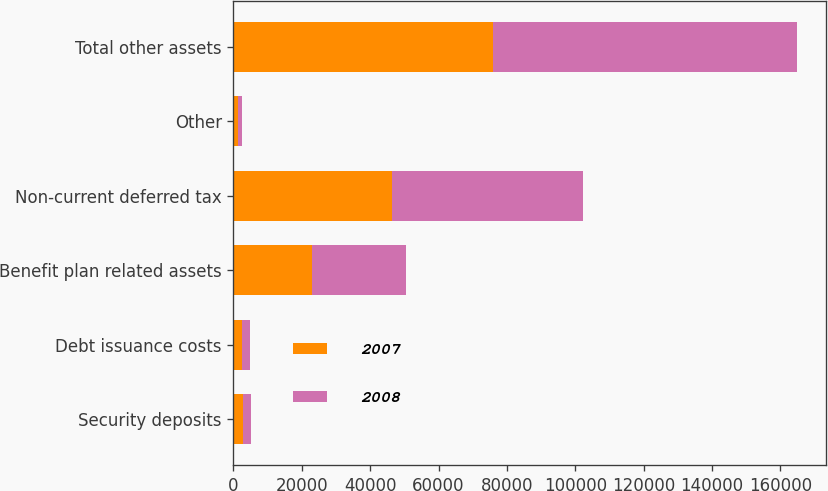Convert chart to OTSL. <chart><loc_0><loc_0><loc_500><loc_500><stacked_bar_chart><ecel><fcel>Security deposits<fcel>Debt issuance costs<fcel>Benefit plan related assets<fcel>Non-current deferred tax<fcel>Other<fcel>Total other assets<nl><fcel>2007<fcel>2796<fcel>2376<fcel>23095<fcel>46378<fcel>1275<fcel>75920<nl><fcel>2008<fcel>2328<fcel>2441<fcel>27248<fcel>55845<fcel>1181<fcel>89043<nl></chart> 